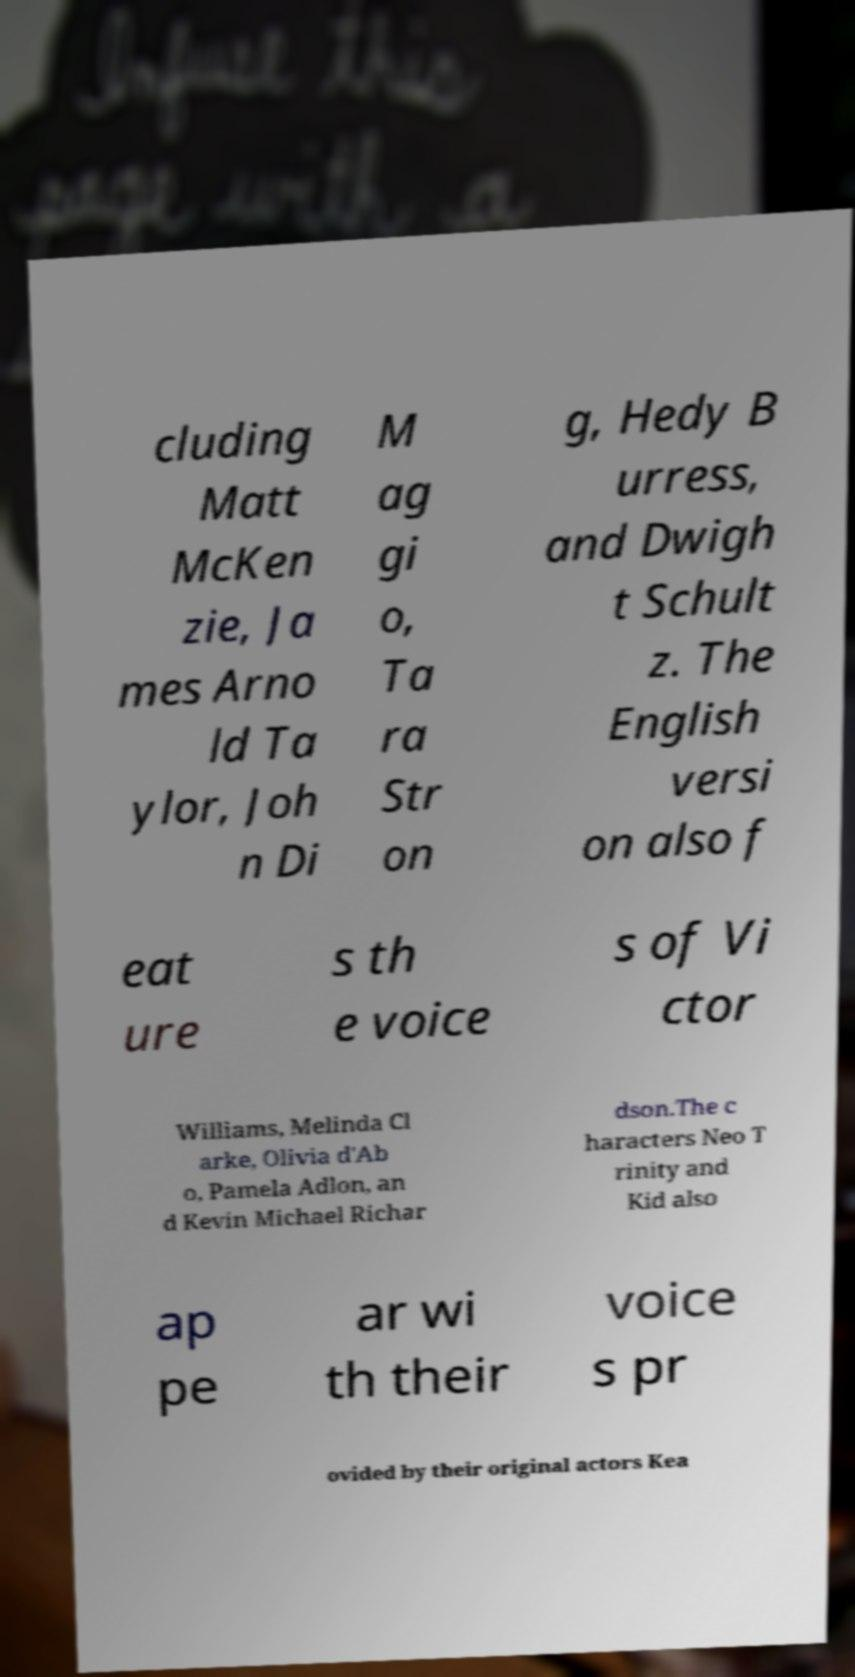I need the written content from this picture converted into text. Can you do that? cluding Matt McKen zie, Ja mes Arno ld Ta ylor, Joh n Di M ag gi o, Ta ra Str on g, Hedy B urress, and Dwigh t Schult z. The English versi on also f eat ure s th e voice s of Vi ctor Williams, Melinda Cl arke, Olivia d'Ab o, Pamela Adlon, an d Kevin Michael Richar dson.The c haracters Neo T rinity and Kid also ap pe ar wi th their voice s pr ovided by their original actors Kea 